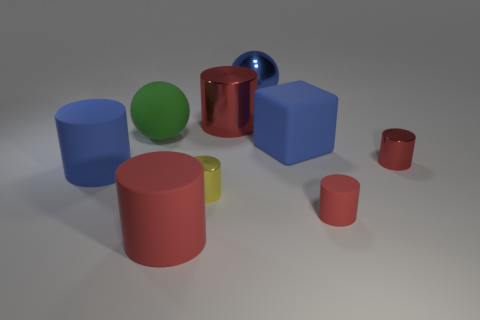Subtract all red cylinders. How many were subtracted if there are1red cylinders left? 3 Subtract all purple cubes. How many red cylinders are left? 4 Subtract 3 cylinders. How many cylinders are left? 3 Subtract all yellow cylinders. How many cylinders are left? 5 Subtract all small matte cylinders. How many cylinders are left? 5 Subtract all blue cylinders. Subtract all cyan cubes. How many cylinders are left? 5 Add 1 shiny cylinders. How many objects exist? 10 Subtract all blocks. How many objects are left? 8 Subtract 0 green cylinders. How many objects are left? 9 Subtract all large green things. Subtract all green objects. How many objects are left? 7 